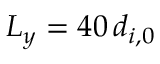Convert formula to latex. <formula><loc_0><loc_0><loc_500><loc_500>{ L _ { y } = 4 0 \, d _ { i , 0 } }</formula> 